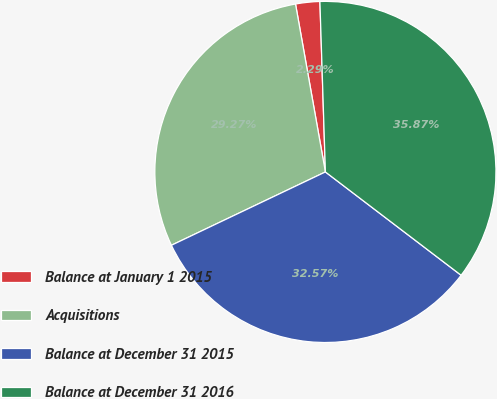<chart> <loc_0><loc_0><loc_500><loc_500><pie_chart><fcel>Balance at January 1 2015<fcel>Acquisitions<fcel>Balance at December 31 2015<fcel>Balance at December 31 2016<nl><fcel>2.29%<fcel>29.27%<fcel>32.57%<fcel>35.87%<nl></chart> 